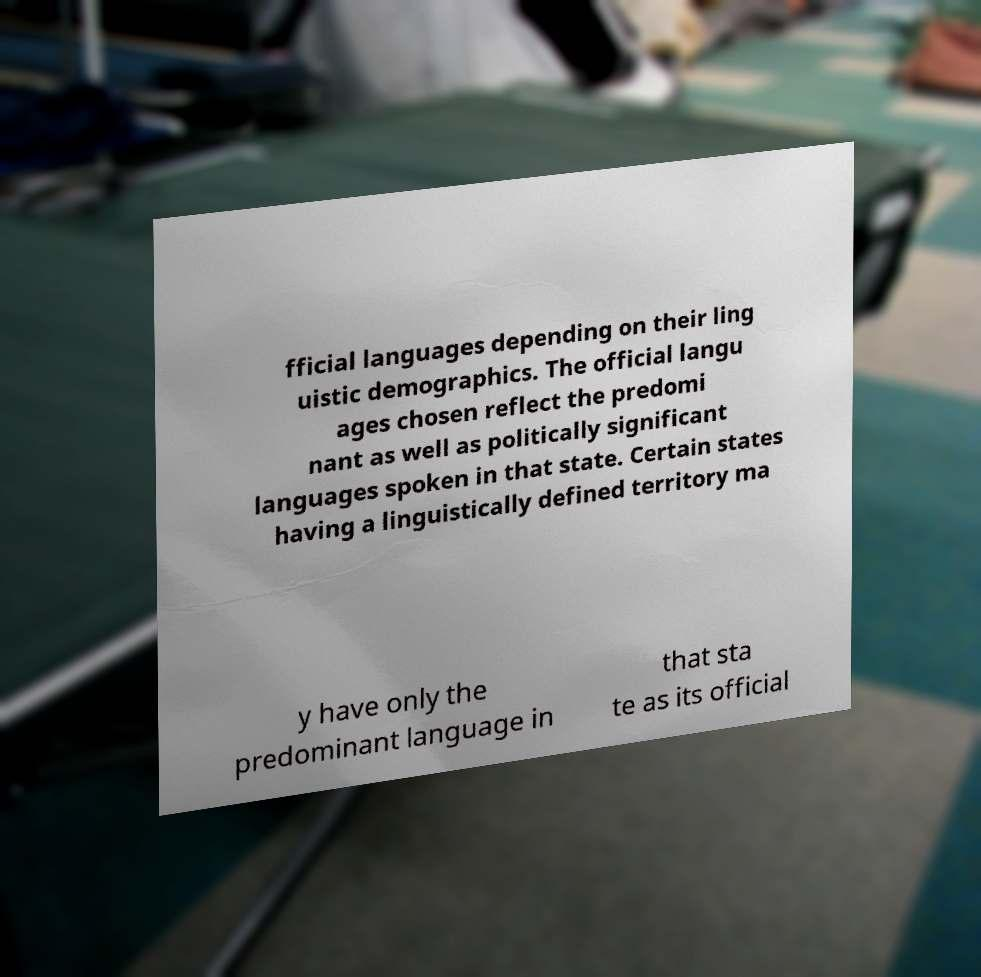Can you read and provide the text displayed in the image?This photo seems to have some interesting text. Can you extract and type it out for me? fficial languages depending on their ling uistic demographics. The official langu ages chosen reflect the predomi nant as well as politically significant languages spoken in that state. Certain states having a linguistically defined territory ma y have only the predominant language in that sta te as its official 